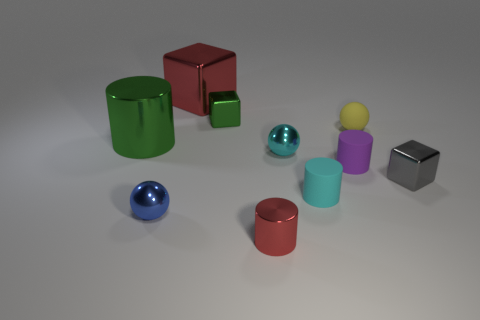Subtract all big red cubes. How many cubes are left? 2 Subtract all blue balls. How many balls are left? 2 Subtract 1 cubes. How many cubes are left? 2 Subtract all spheres. How many objects are left? 7 Subtract all tiny gray things. Subtract all small green metal cubes. How many objects are left? 8 Add 4 red metallic cylinders. How many red metallic cylinders are left? 5 Add 5 gray matte spheres. How many gray matte spheres exist? 5 Subtract 0 red spheres. How many objects are left? 10 Subtract all blue spheres. Subtract all gray cylinders. How many spheres are left? 2 Subtract all brown cylinders. How many green cubes are left? 1 